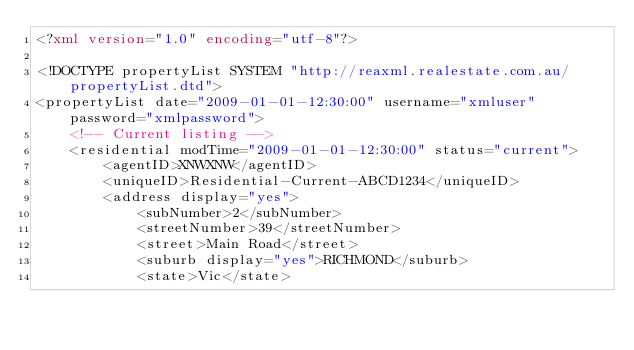<code> <loc_0><loc_0><loc_500><loc_500><_XML_><?xml version="1.0" encoding="utf-8"?>

<!DOCTYPE propertyList SYSTEM "http://reaxml.realestate.com.au/propertyList.dtd">
<propertyList date="2009-01-01-12:30:00" username="xmluser" password="xmlpassword">
    <!-- Current listing -->
    <residential modTime="2009-01-01-12:30:00" status="current">
        <agentID>XNWXNW</agentID>
        <uniqueID>Residential-Current-ABCD1234</uniqueID>
        <address display="yes">
            <subNumber>2</subNumber>
            <streetNumber>39</streetNumber>
            <street>Main Road</street>
            <suburb display="yes">RICHMOND</suburb>
            <state>Vic</state></code> 